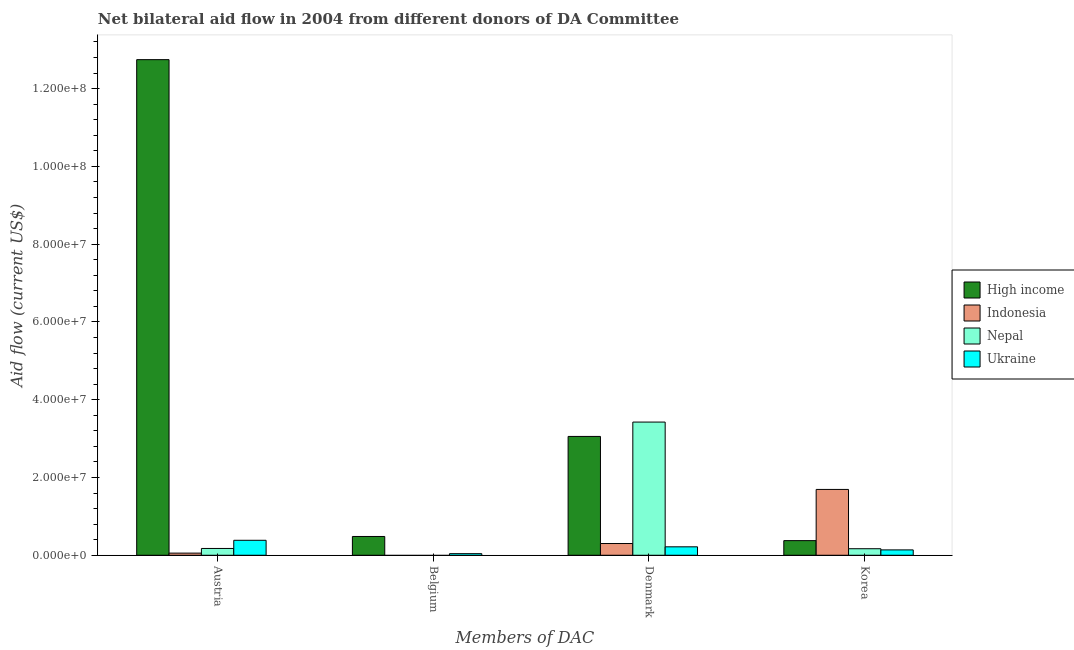How many different coloured bars are there?
Make the answer very short. 4. Are the number of bars per tick equal to the number of legend labels?
Provide a succinct answer. No. How many bars are there on the 1st tick from the left?
Your answer should be very brief. 4. How many bars are there on the 1st tick from the right?
Your response must be concise. 4. What is the amount of aid given by denmark in High income?
Make the answer very short. 3.06e+07. Across all countries, what is the maximum amount of aid given by austria?
Provide a short and direct response. 1.27e+08. Across all countries, what is the minimum amount of aid given by korea?
Provide a succinct answer. 1.38e+06. In which country was the amount of aid given by belgium maximum?
Your answer should be compact. High income. What is the total amount of aid given by denmark in the graph?
Provide a short and direct response. 7.00e+07. What is the difference between the amount of aid given by austria in Ukraine and that in Indonesia?
Ensure brevity in your answer.  3.30e+06. What is the difference between the amount of aid given by denmark in High income and the amount of aid given by belgium in Ukraine?
Provide a succinct answer. 3.02e+07. What is the average amount of aid given by denmark per country?
Make the answer very short. 1.75e+07. What is the difference between the amount of aid given by belgium and amount of aid given by korea in Ukraine?
Provide a succinct answer. -9.70e+05. In how many countries, is the amount of aid given by belgium greater than 8000000 US$?
Provide a short and direct response. 0. What is the ratio of the amount of aid given by denmark in High income to that in Indonesia?
Give a very brief answer. 10.12. Is the amount of aid given by denmark in Indonesia less than that in High income?
Make the answer very short. Yes. Is the difference between the amount of aid given by austria in Indonesia and High income greater than the difference between the amount of aid given by korea in Indonesia and High income?
Keep it short and to the point. No. What is the difference between the highest and the second highest amount of aid given by austria?
Provide a short and direct response. 1.24e+08. What is the difference between the highest and the lowest amount of aid given by belgium?
Offer a very short reply. 4.83e+06. Is it the case that in every country, the sum of the amount of aid given by denmark and amount of aid given by austria is greater than the sum of amount of aid given by korea and amount of aid given by belgium?
Your answer should be very brief. No. Is it the case that in every country, the sum of the amount of aid given by austria and amount of aid given by belgium is greater than the amount of aid given by denmark?
Make the answer very short. No. How many bars are there?
Provide a succinct answer. 14. Are all the bars in the graph horizontal?
Offer a terse response. No. What is the difference between two consecutive major ticks on the Y-axis?
Keep it short and to the point. 2.00e+07. Does the graph contain any zero values?
Offer a very short reply. Yes. What is the title of the graph?
Make the answer very short. Net bilateral aid flow in 2004 from different donors of DA Committee. What is the label or title of the X-axis?
Provide a succinct answer. Members of DAC. What is the label or title of the Y-axis?
Offer a very short reply. Aid flow (current US$). What is the Aid flow (current US$) in High income in Austria?
Provide a succinct answer. 1.27e+08. What is the Aid flow (current US$) of Nepal in Austria?
Offer a terse response. 1.75e+06. What is the Aid flow (current US$) of Ukraine in Austria?
Your response must be concise. 3.85e+06. What is the Aid flow (current US$) in High income in Belgium?
Your answer should be very brief. 4.83e+06. What is the Aid flow (current US$) of Nepal in Belgium?
Offer a terse response. 0. What is the Aid flow (current US$) of Ukraine in Belgium?
Give a very brief answer. 4.10e+05. What is the Aid flow (current US$) of High income in Denmark?
Provide a succinct answer. 3.06e+07. What is the Aid flow (current US$) in Indonesia in Denmark?
Ensure brevity in your answer.  3.02e+06. What is the Aid flow (current US$) of Nepal in Denmark?
Make the answer very short. 3.42e+07. What is the Aid flow (current US$) of Ukraine in Denmark?
Your answer should be compact. 2.17e+06. What is the Aid flow (current US$) in High income in Korea?
Keep it short and to the point. 3.76e+06. What is the Aid flow (current US$) of Indonesia in Korea?
Give a very brief answer. 1.69e+07. What is the Aid flow (current US$) in Nepal in Korea?
Give a very brief answer. 1.68e+06. What is the Aid flow (current US$) of Ukraine in Korea?
Offer a very short reply. 1.38e+06. Across all Members of DAC, what is the maximum Aid flow (current US$) of High income?
Your answer should be compact. 1.27e+08. Across all Members of DAC, what is the maximum Aid flow (current US$) of Indonesia?
Offer a terse response. 1.69e+07. Across all Members of DAC, what is the maximum Aid flow (current US$) of Nepal?
Give a very brief answer. 3.42e+07. Across all Members of DAC, what is the maximum Aid flow (current US$) in Ukraine?
Make the answer very short. 3.85e+06. Across all Members of DAC, what is the minimum Aid flow (current US$) of High income?
Make the answer very short. 3.76e+06. Across all Members of DAC, what is the minimum Aid flow (current US$) of Nepal?
Keep it short and to the point. 0. Across all Members of DAC, what is the minimum Aid flow (current US$) of Ukraine?
Your answer should be compact. 4.10e+05. What is the total Aid flow (current US$) in High income in the graph?
Offer a terse response. 1.67e+08. What is the total Aid flow (current US$) in Indonesia in the graph?
Your response must be concise. 2.05e+07. What is the total Aid flow (current US$) of Nepal in the graph?
Provide a succinct answer. 3.77e+07. What is the total Aid flow (current US$) in Ukraine in the graph?
Offer a terse response. 7.81e+06. What is the difference between the Aid flow (current US$) of High income in Austria and that in Belgium?
Provide a short and direct response. 1.23e+08. What is the difference between the Aid flow (current US$) of Ukraine in Austria and that in Belgium?
Your response must be concise. 3.44e+06. What is the difference between the Aid flow (current US$) of High income in Austria and that in Denmark?
Give a very brief answer. 9.69e+07. What is the difference between the Aid flow (current US$) in Indonesia in Austria and that in Denmark?
Provide a succinct answer. -2.47e+06. What is the difference between the Aid flow (current US$) of Nepal in Austria and that in Denmark?
Keep it short and to the point. -3.25e+07. What is the difference between the Aid flow (current US$) in Ukraine in Austria and that in Denmark?
Give a very brief answer. 1.68e+06. What is the difference between the Aid flow (current US$) in High income in Austria and that in Korea?
Your answer should be compact. 1.24e+08. What is the difference between the Aid flow (current US$) of Indonesia in Austria and that in Korea?
Provide a succinct answer. -1.64e+07. What is the difference between the Aid flow (current US$) of Ukraine in Austria and that in Korea?
Your answer should be compact. 2.47e+06. What is the difference between the Aid flow (current US$) in High income in Belgium and that in Denmark?
Give a very brief answer. -2.57e+07. What is the difference between the Aid flow (current US$) in Ukraine in Belgium and that in Denmark?
Ensure brevity in your answer.  -1.76e+06. What is the difference between the Aid flow (current US$) in High income in Belgium and that in Korea?
Your answer should be very brief. 1.07e+06. What is the difference between the Aid flow (current US$) of Ukraine in Belgium and that in Korea?
Your answer should be compact. -9.70e+05. What is the difference between the Aid flow (current US$) in High income in Denmark and that in Korea?
Your answer should be compact. 2.68e+07. What is the difference between the Aid flow (current US$) in Indonesia in Denmark and that in Korea?
Ensure brevity in your answer.  -1.39e+07. What is the difference between the Aid flow (current US$) in Nepal in Denmark and that in Korea?
Ensure brevity in your answer.  3.26e+07. What is the difference between the Aid flow (current US$) of Ukraine in Denmark and that in Korea?
Provide a short and direct response. 7.90e+05. What is the difference between the Aid flow (current US$) of High income in Austria and the Aid flow (current US$) of Ukraine in Belgium?
Ensure brevity in your answer.  1.27e+08. What is the difference between the Aid flow (current US$) of Nepal in Austria and the Aid flow (current US$) of Ukraine in Belgium?
Your answer should be compact. 1.34e+06. What is the difference between the Aid flow (current US$) in High income in Austria and the Aid flow (current US$) in Indonesia in Denmark?
Provide a succinct answer. 1.24e+08. What is the difference between the Aid flow (current US$) of High income in Austria and the Aid flow (current US$) of Nepal in Denmark?
Offer a terse response. 9.32e+07. What is the difference between the Aid flow (current US$) of High income in Austria and the Aid flow (current US$) of Ukraine in Denmark?
Offer a very short reply. 1.25e+08. What is the difference between the Aid flow (current US$) of Indonesia in Austria and the Aid flow (current US$) of Nepal in Denmark?
Your answer should be compact. -3.37e+07. What is the difference between the Aid flow (current US$) in Indonesia in Austria and the Aid flow (current US$) in Ukraine in Denmark?
Keep it short and to the point. -1.62e+06. What is the difference between the Aid flow (current US$) of Nepal in Austria and the Aid flow (current US$) of Ukraine in Denmark?
Offer a very short reply. -4.20e+05. What is the difference between the Aid flow (current US$) of High income in Austria and the Aid flow (current US$) of Indonesia in Korea?
Provide a succinct answer. 1.11e+08. What is the difference between the Aid flow (current US$) of High income in Austria and the Aid flow (current US$) of Nepal in Korea?
Your answer should be compact. 1.26e+08. What is the difference between the Aid flow (current US$) in High income in Austria and the Aid flow (current US$) in Ukraine in Korea?
Offer a very short reply. 1.26e+08. What is the difference between the Aid flow (current US$) in Indonesia in Austria and the Aid flow (current US$) in Nepal in Korea?
Offer a very short reply. -1.13e+06. What is the difference between the Aid flow (current US$) of Indonesia in Austria and the Aid flow (current US$) of Ukraine in Korea?
Your answer should be compact. -8.30e+05. What is the difference between the Aid flow (current US$) in Nepal in Austria and the Aid flow (current US$) in Ukraine in Korea?
Your answer should be very brief. 3.70e+05. What is the difference between the Aid flow (current US$) of High income in Belgium and the Aid flow (current US$) of Indonesia in Denmark?
Offer a very short reply. 1.81e+06. What is the difference between the Aid flow (current US$) of High income in Belgium and the Aid flow (current US$) of Nepal in Denmark?
Offer a very short reply. -2.94e+07. What is the difference between the Aid flow (current US$) in High income in Belgium and the Aid flow (current US$) in Ukraine in Denmark?
Your response must be concise. 2.66e+06. What is the difference between the Aid flow (current US$) in High income in Belgium and the Aid flow (current US$) in Indonesia in Korea?
Your answer should be compact. -1.21e+07. What is the difference between the Aid flow (current US$) in High income in Belgium and the Aid flow (current US$) in Nepal in Korea?
Offer a very short reply. 3.15e+06. What is the difference between the Aid flow (current US$) in High income in Belgium and the Aid flow (current US$) in Ukraine in Korea?
Provide a short and direct response. 3.45e+06. What is the difference between the Aid flow (current US$) of High income in Denmark and the Aid flow (current US$) of Indonesia in Korea?
Make the answer very short. 1.36e+07. What is the difference between the Aid flow (current US$) of High income in Denmark and the Aid flow (current US$) of Nepal in Korea?
Your response must be concise. 2.89e+07. What is the difference between the Aid flow (current US$) in High income in Denmark and the Aid flow (current US$) in Ukraine in Korea?
Provide a short and direct response. 2.92e+07. What is the difference between the Aid flow (current US$) in Indonesia in Denmark and the Aid flow (current US$) in Nepal in Korea?
Offer a terse response. 1.34e+06. What is the difference between the Aid flow (current US$) in Indonesia in Denmark and the Aid flow (current US$) in Ukraine in Korea?
Provide a succinct answer. 1.64e+06. What is the difference between the Aid flow (current US$) of Nepal in Denmark and the Aid flow (current US$) of Ukraine in Korea?
Provide a succinct answer. 3.29e+07. What is the average Aid flow (current US$) of High income per Members of DAC?
Keep it short and to the point. 4.16e+07. What is the average Aid flow (current US$) of Indonesia per Members of DAC?
Your answer should be compact. 5.12e+06. What is the average Aid flow (current US$) in Nepal per Members of DAC?
Keep it short and to the point. 9.42e+06. What is the average Aid flow (current US$) in Ukraine per Members of DAC?
Make the answer very short. 1.95e+06. What is the difference between the Aid flow (current US$) of High income and Aid flow (current US$) of Indonesia in Austria?
Ensure brevity in your answer.  1.27e+08. What is the difference between the Aid flow (current US$) in High income and Aid flow (current US$) in Nepal in Austria?
Give a very brief answer. 1.26e+08. What is the difference between the Aid flow (current US$) of High income and Aid flow (current US$) of Ukraine in Austria?
Provide a succinct answer. 1.24e+08. What is the difference between the Aid flow (current US$) of Indonesia and Aid flow (current US$) of Nepal in Austria?
Offer a terse response. -1.20e+06. What is the difference between the Aid flow (current US$) of Indonesia and Aid flow (current US$) of Ukraine in Austria?
Offer a terse response. -3.30e+06. What is the difference between the Aid flow (current US$) of Nepal and Aid flow (current US$) of Ukraine in Austria?
Offer a terse response. -2.10e+06. What is the difference between the Aid flow (current US$) of High income and Aid flow (current US$) of Ukraine in Belgium?
Ensure brevity in your answer.  4.42e+06. What is the difference between the Aid flow (current US$) of High income and Aid flow (current US$) of Indonesia in Denmark?
Your response must be concise. 2.75e+07. What is the difference between the Aid flow (current US$) in High income and Aid flow (current US$) in Nepal in Denmark?
Your answer should be very brief. -3.69e+06. What is the difference between the Aid flow (current US$) of High income and Aid flow (current US$) of Ukraine in Denmark?
Offer a very short reply. 2.84e+07. What is the difference between the Aid flow (current US$) in Indonesia and Aid flow (current US$) in Nepal in Denmark?
Your response must be concise. -3.12e+07. What is the difference between the Aid flow (current US$) in Indonesia and Aid flow (current US$) in Ukraine in Denmark?
Your response must be concise. 8.50e+05. What is the difference between the Aid flow (current US$) in Nepal and Aid flow (current US$) in Ukraine in Denmark?
Provide a succinct answer. 3.21e+07. What is the difference between the Aid flow (current US$) of High income and Aid flow (current US$) of Indonesia in Korea?
Provide a succinct answer. -1.32e+07. What is the difference between the Aid flow (current US$) of High income and Aid flow (current US$) of Nepal in Korea?
Make the answer very short. 2.08e+06. What is the difference between the Aid flow (current US$) of High income and Aid flow (current US$) of Ukraine in Korea?
Keep it short and to the point. 2.38e+06. What is the difference between the Aid flow (current US$) in Indonesia and Aid flow (current US$) in Nepal in Korea?
Offer a terse response. 1.52e+07. What is the difference between the Aid flow (current US$) in Indonesia and Aid flow (current US$) in Ukraine in Korea?
Give a very brief answer. 1.56e+07. What is the difference between the Aid flow (current US$) of Nepal and Aid flow (current US$) of Ukraine in Korea?
Provide a short and direct response. 3.00e+05. What is the ratio of the Aid flow (current US$) in High income in Austria to that in Belgium?
Make the answer very short. 26.39. What is the ratio of the Aid flow (current US$) of Ukraine in Austria to that in Belgium?
Provide a short and direct response. 9.39. What is the ratio of the Aid flow (current US$) of High income in Austria to that in Denmark?
Your response must be concise. 4.17. What is the ratio of the Aid flow (current US$) in Indonesia in Austria to that in Denmark?
Your response must be concise. 0.18. What is the ratio of the Aid flow (current US$) in Nepal in Austria to that in Denmark?
Your answer should be compact. 0.05. What is the ratio of the Aid flow (current US$) in Ukraine in Austria to that in Denmark?
Ensure brevity in your answer.  1.77. What is the ratio of the Aid flow (current US$) in High income in Austria to that in Korea?
Offer a very short reply. 33.9. What is the ratio of the Aid flow (current US$) of Indonesia in Austria to that in Korea?
Make the answer very short. 0.03. What is the ratio of the Aid flow (current US$) in Nepal in Austria to that in Korea?
Your answer should be very brief. 1.04. What is the ratio of the Aid flow (current US$) in Ukraine in Austria to that in Korea?
Your answer should be very brief. 2.79. What is the ratio of the Aid flow (current US$) in High income in Belgium to that in Denmark?
Give a very brief answer. 0.16. What is the ratio of the Aid flow (current US$) of Ukraine in Belgium to that in Denmark?
Provide a succinct answer. 0.19. What is the ratio of the Aid flow (current US$) in High income in Belgium to that in Korea?
Keep it short and to the point. 1.28. What is the ratio of the Aid flow (current US$) in Ukraine in Belgium to that in Korea?
Offer a terse response. 0.3. What is the ratio of the Aid flow (current US$) in High income in Denmark to that in Korea?
Make the answer very short. 8.13. What is the ratio of the Aid flow (current US$) in Indonesia in Denmark to that in Korea?
Provide a succinct answer. 0.18. What is the ratio of the Aid flow (current US$) of Nepal in Denmark to that in Korea?
Your answer should be compact. 20.39. What is the ratio of the Aid flow (current US$) of Ukraine in Denmark to that in Korea?
Provide a succinct answer. 1.57. What is the difference between the highest and the second highest Aid flow (current US$) of High income?
Provide a short and direct response. 9.69e+07. What is the difference between the highest and the second highest Aid flow (current US$) of Indonesia?
Offer a very short reply. 1.39e+07. What is the difference between the highest and the second highest Aid flow (current US$) of Nepal?
Your answer should be very brief. 3.25e+07. What is the difference between the highest and the second highest Aid flow (current US$) in Ukraine?
Your response must be concise. 1.68e+06. What is the difference between the highest and the lowest Aid flow (current US$) of High income?
Your answer should be compact. 1.24e+08. What is the difference between the highest and the lowest Aid flow (current US$) of Indonesia?
Your response must be concise. 1.69e+07. What is the difference between the highest and the lowest Aid flow (current US$) in Nepal?
Provide a succinct answer. 3.42e+07. What is the difference between the highest and the lowest Aid flow (current US$) of Ukraine?
Your answer should be very brief. 3.44e+06. 